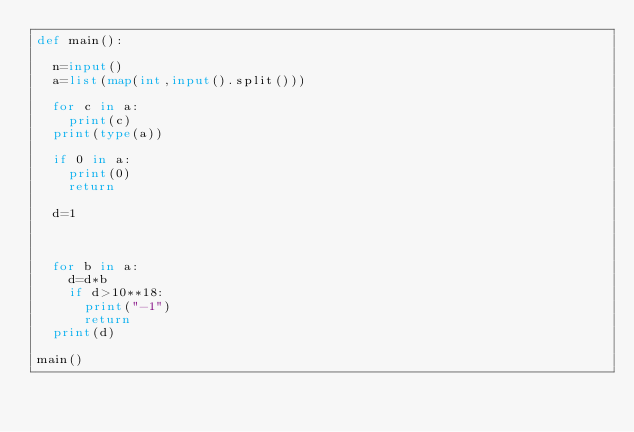Convert code to text. <code><loc_0><loc_0><loc_500><loc_500><_Python_>def main():

	n=input()
	a=list(map(int,input().split()))
    
	for c in a:
		print(c)
	print(type(a))
	
	if 0 in a:
		print(0)
		return

	d=1
    
	

	for b in a:
		d=d*b
		if d>10**18:
			print("-1")
			return
	print(d)

main()</code> 